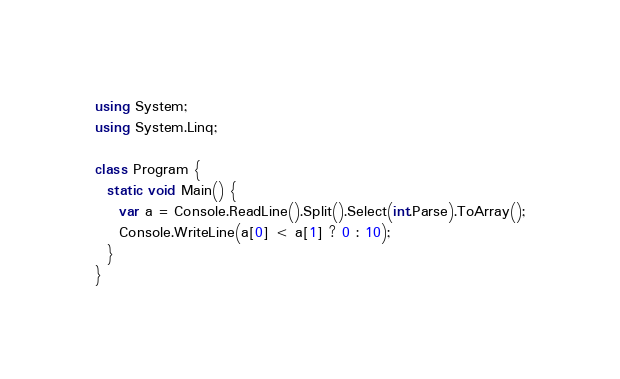Convert code to text. <code><loc_0><loc_0><loc_500><loc_500><_C#_>using System;
using System.Linq;

class Program {
  static void Main() {
    var a = Console.ReadLine().Split().Select(int.Parse).ToArray();
    Console.WriteLine(a[0] < a[1] ? 0 : 10);
  }
}</code> 